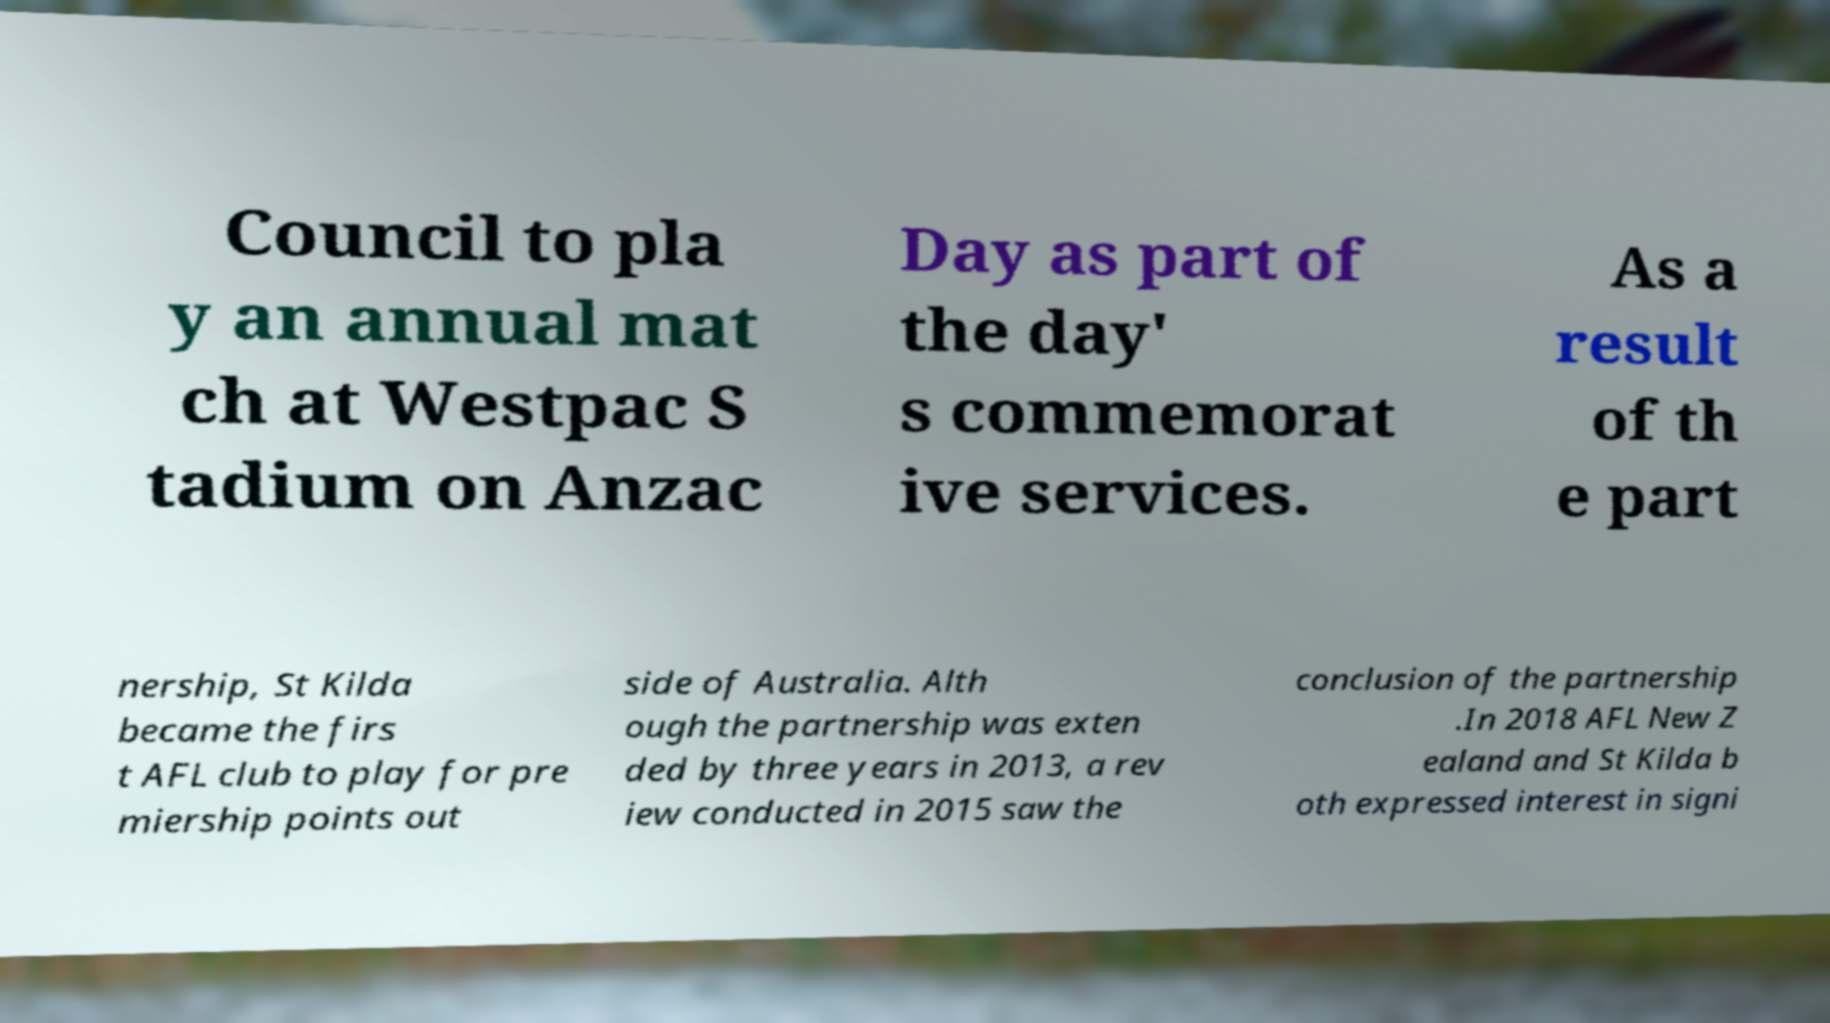There's text embedded in this image that I need extracted. Can you transcribe it verbatim? Council to pla y an annual mat ch at Westpac S tadium on Anzac Day as part of the day' s commemorat ive services. As a result of th e part nership, St Kilda became the firs t AFL club to play for pre miership points out side of Australia. Alth ough the partnership was exten ded by three years in 2013, a rev iew conducted in 2015 saw the conclusion of the partnership .In 2018 AFL New Z ealand and St Kilda b oth expressed interest in signi 